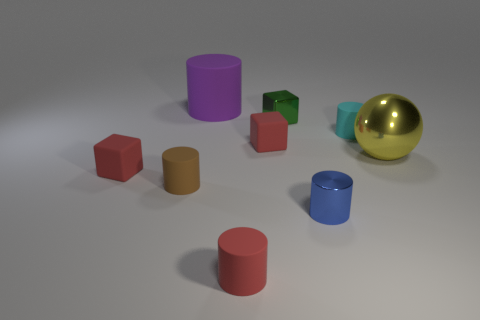Add 1 large yellow things. How many objects exist? 10 Subtract all small red cubes. How many cubes are left? 1 Subtract all balls. How many objects are left? 8 Subtract 3 cylinders. How many cylinders are left? 2 Subtract all blue cylinders. How many cylinders are left? 4 Subtract 1 green blocks. How many objects are left? 8 Subtract all purple cylinders. Subtract all purple blocks. How many cylinders are left? 4 Subtract all green cylinders. How many green blocks are left? 1 Subtract all cyan objects. Subtract all brown rubber things. How many objects are left? 7 Add 2 yellow balls. How many yellow balls are left? 3 